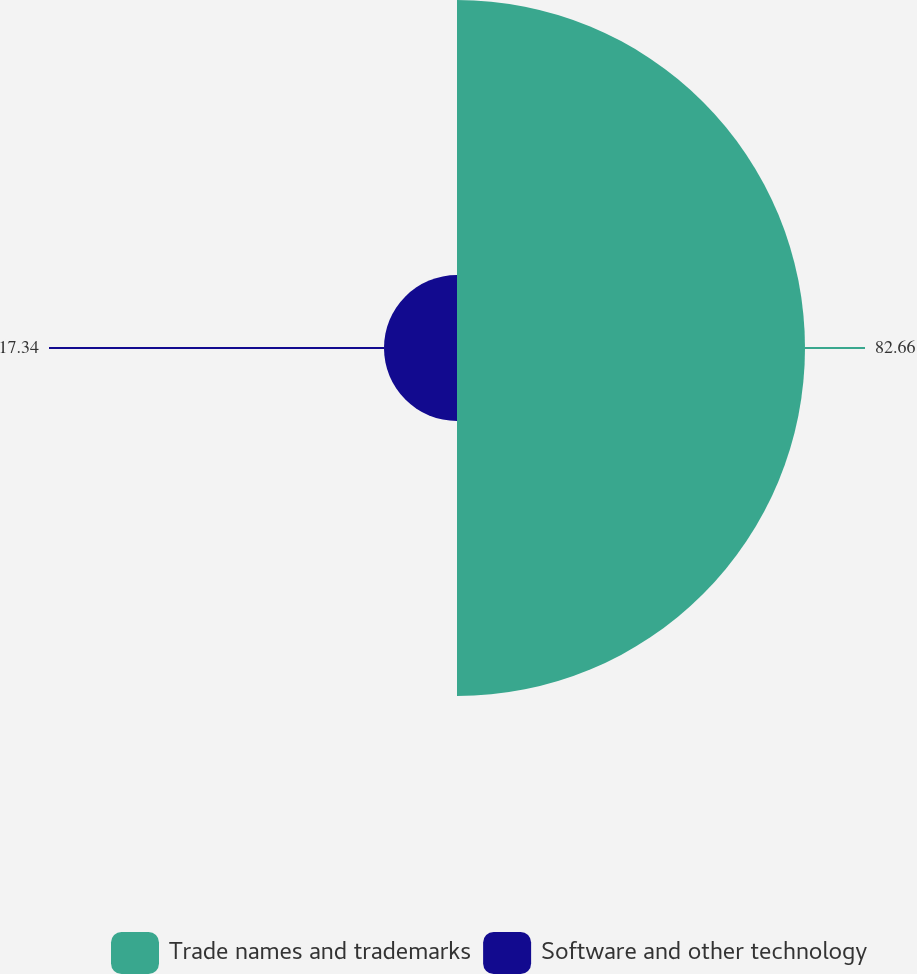Convert chart. <chart><loc_0><loc_0><loc_500><loc_500><pie_chart><fcel>Trade names and trademarks<fcel>Software and other technology<nl><fcel>82.66%<fcel>17.34%<nl></chart> 